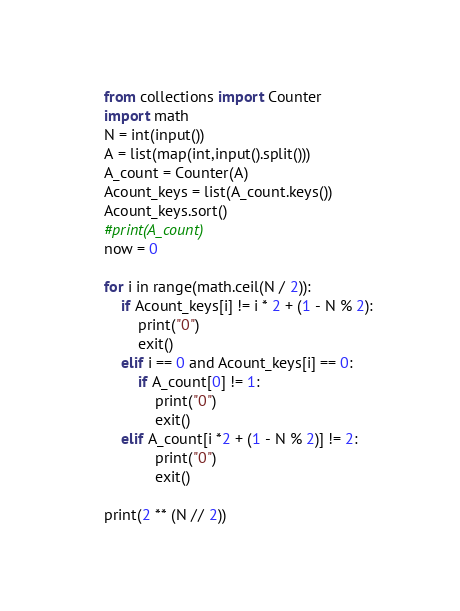<code> <loc_0><loc_0><loc_500><loc_500><_Python_>from collections import Counter
import math
N = int(input())
A = list(map(int,input().split()))
A_count = Counter(A)
Acount_keys = list(A_count.keys())
Acount_keys.sort()
#print(A_count)
now = 0

for i in range(math.ceil(N / 2)):
    if Acount_keys[i] != i * 2 + (1 - N % 2):
        print("0")
        exit()
    elif i == 0 and Acount_keys[i] == 0:
        if A_count[0] != 1:
            print("0")
            exit()
    elif A_count[i *2 + (1 - N % 2)] != 2:
            print("0")
            exit()

print(2 ** (N // 2))

</code> 